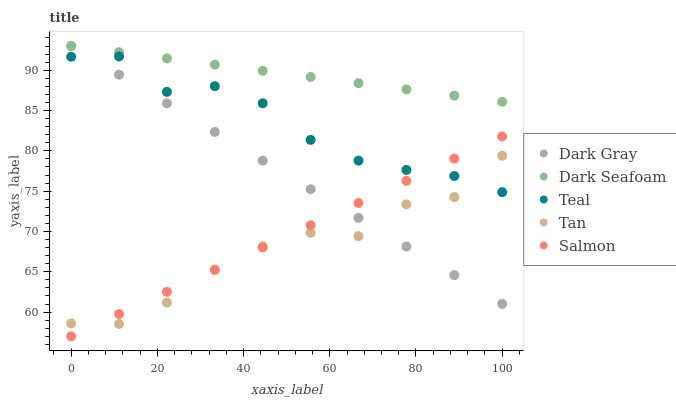Does Tan have the minimum area under the curve?
Answer yes or no. Yes. Does Dark Seafoam have the maximum area under the curve?
Answer yes or no. Yes. Does Salmon have the minimum area under the curve?
Answer yes or no. No. Does Salmon have the maximum area under the curve?
Answer yes or no. No. Is Dark Seafoam the smoothest?
Answer yes or no. Yes. Is Tan the roughest?
Answer yes or no. Yes. Is Salmon the smoothest?
Answer yes or no. No. Is Salmon the roughest?
Answer yes or no. No. Does Salmon have the lowest value?
Answer yes or no. Yes. Does Dark Seafoam have the lowest value?
Answer yes or no. No. Does Dark Seafoam have the highest value?
Answer yes or no. Yes. Does Salmon have the highest value?
Answer yes or no. No. Is Tan less than Dark Seafoam?
Answer yes or no. Yes. Is Dark Seafoam greater than Teal?
Answer yes or no. Yes. Does Dark Gray intersect Dark Seafoam?
Answer yes or no. Yes. Is Dark Gray less than Dark Seafoam?
Answer yes or no. No. Is Dark Gray greater than Dark Seafoam?
Answer yes or no. No. Does Tan intersect Dark Seafoam?
Answer yes or no. No. 